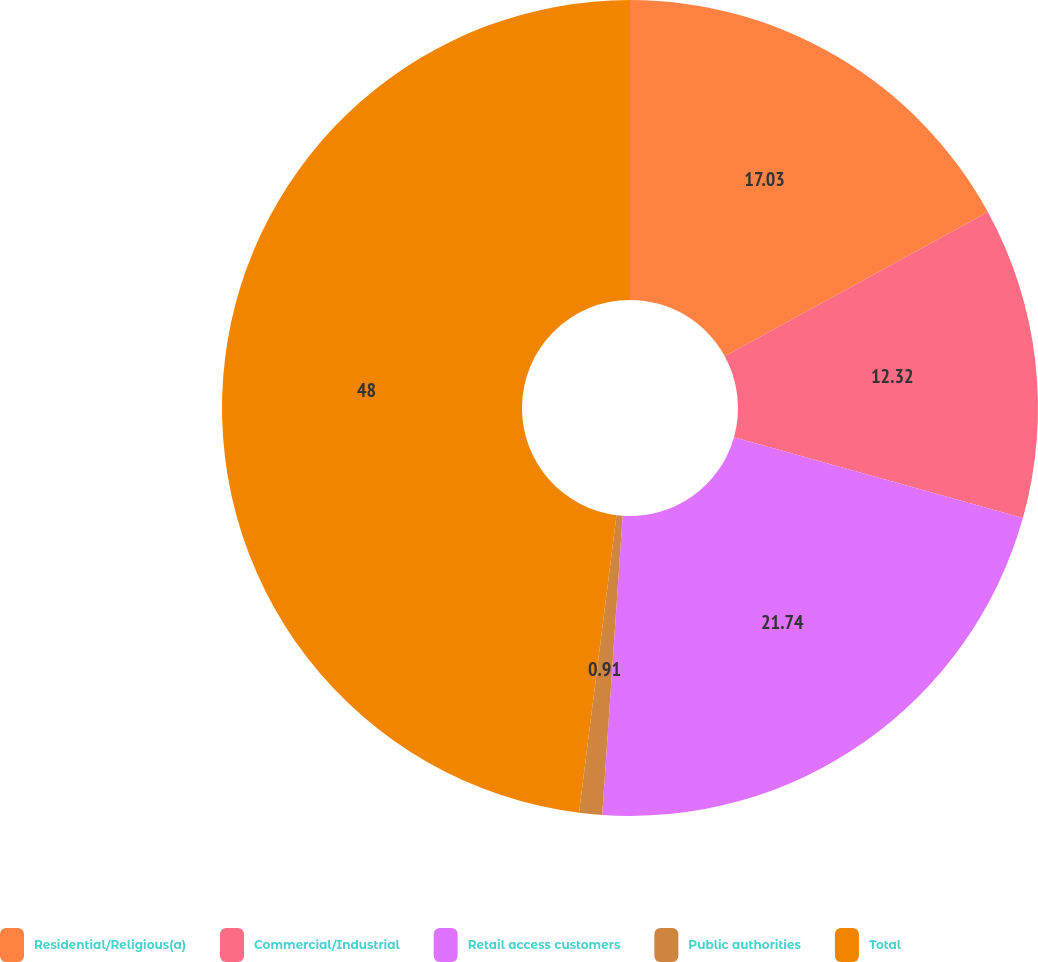Convert chart. <chart><loc_0><loc_0><loc_500><loc_500><pie_chart><fcel>Residential/Religious(a)<fcel>Commercial/Industrial<fcel>Retail access customers<fcel>Public authorities<fcel>Total<nl><fcel>17.03%<fcel>12.32%<fcel>21.74%<fcel>0.91%<fcel>48.01%<nl></chart> 